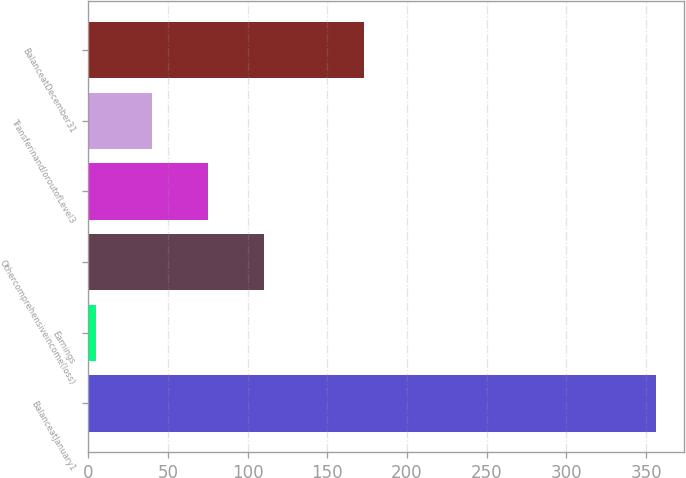Convert chart. <chart><loc_0><loc_0><loc_500><loc_500><bar_chart><fcel>BalanceatJanuary1<fcel>Earnings<fcel>Othercomprehensiveincome(loss)<fcel>Unnamed: 3<fcel>Transferinand/oroutofLevel3<fcel>BalanceatDecember31<nl><fcel>356<fcel>5<fcel>110.3<fcel>75.2<fcel>40.1<fcel>173<nl></chart> 